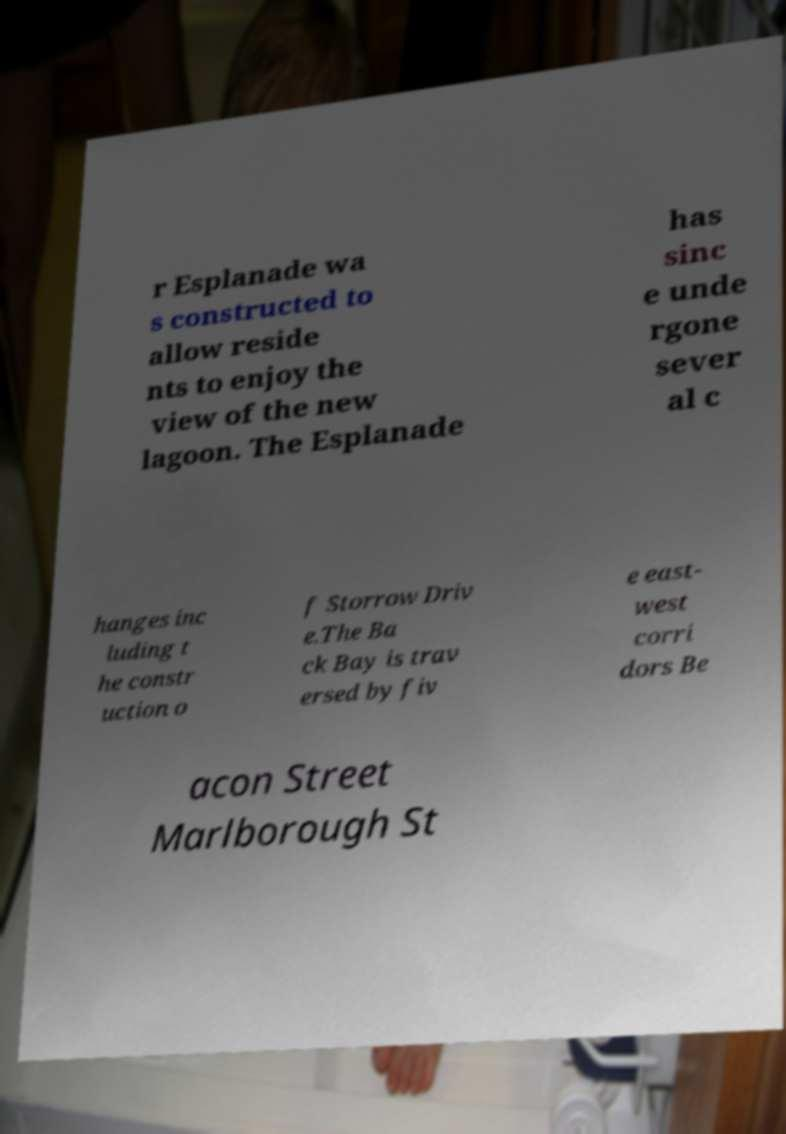Could you extract and type out the text from this image? r Esplanade wa s constructed to allow reside nts to enjoy the view of the new lagoon. The Esplanade has sinc e unde rgone sever al c hanges inc luding t he constr uction o f Storrow Driv e.The Ba ck Bay is trav ersed by fiv e east- west corri dors Be acon Street Marlborough St 